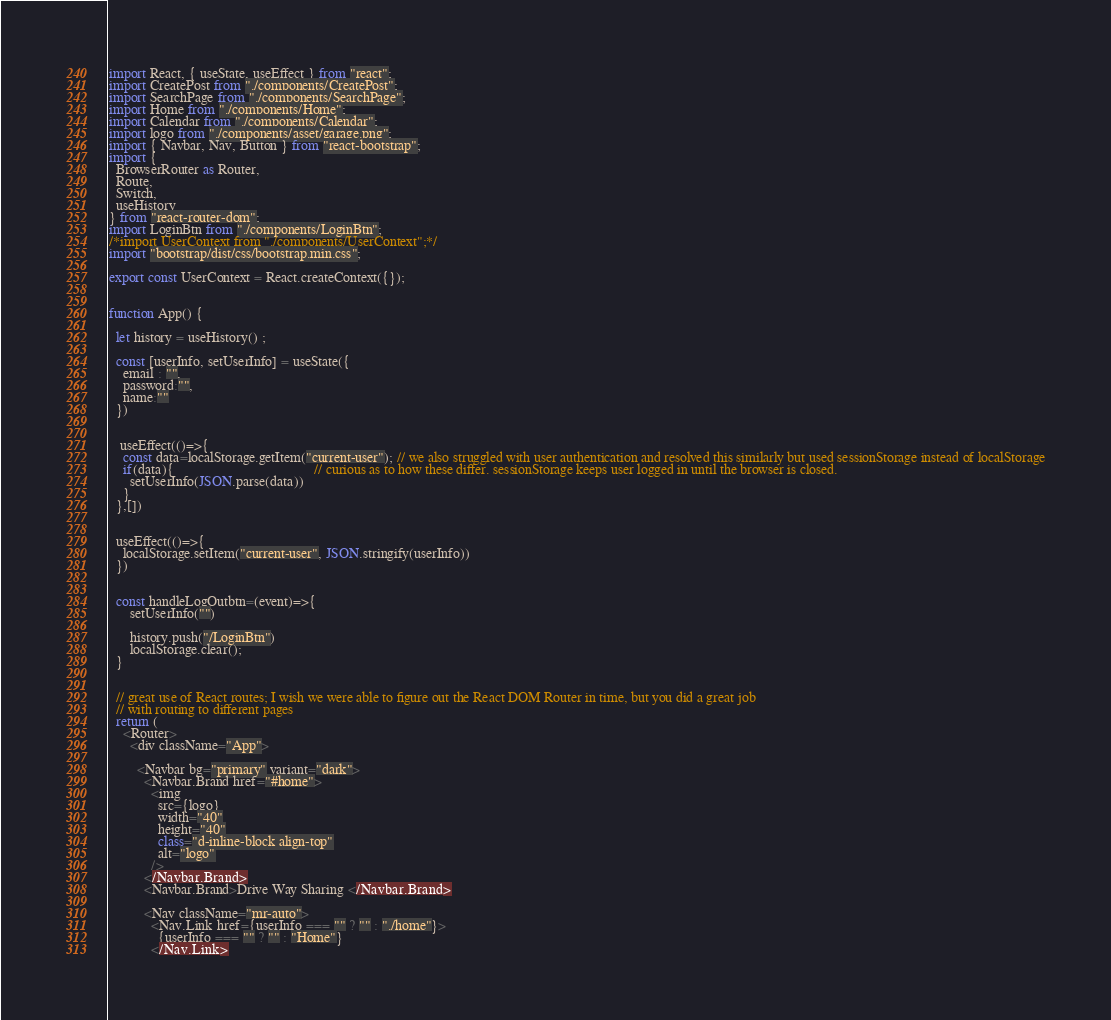<code> <loc_0><loc_0><loc_500><loc_500><_JavaScript_>import React, { useState, useEffect } from "react";
import CreatePost from "./components/CreatePost";
import SearchPage from "./components/SearchPage";
import Home from "./components/Home";
import Calendar from "./components/Calendar";
import logo from "./components/asset/garage.png";
import { Navbar, Nav, Button } from "react-bootstrap";
import {
  BrowserRouter as Router,
  Route,
  Switch,
  useHistory
} from "react-router-dom";
import LoginBtn from "./components/LoginBtn";
/*import UserContext from "./components/UserContext";*/
import "bootstrap/dist/css/bootstrap.min.css";

export const UserContext = React.createContext({});


function App() {

  let history = useHistory() ;

  const [userInfo, setUserInfo] = useState({
    email : "",
    password:"",
    name:""
  })


   useEffect(()=>{
    const data=localStorage.getItem("current-user"); // we also struggled with user authentication and resolved this similarly but used sessionStorage instead of localStorage
    if(data){                                        // curious as to how these differ. sessionStorage keeps user logged in until the browser is closed.
      setUserInfo(JSON.parse(data))
    }
  },[])


  useEffect(()=>{
    localStorage.setItem("current-user", JSON.stringify(userInfo))
  })


  const handleLogOutbtn=(event)=>{
      setUserInfo("")
      
      history.push("/LoginBtn")
      localStorage.clear();
  }


  // great use of React routes; I wish we were able to figure out the React DOM Router in time, but you did a great job
  // with routing to different pages
  return (
    <Router>
      <div className="App">
      
        <Navbar bg="primary" variant="dark">
          <Navbar.Brand href="#home">
            <img
              src={logo}
              width="40"
              height="40"
              class="d-inline-block align-top"
              alt="logo"
            />
          </Navbar.Brand>
          <Navbar.Brand>Drive Way Sharing </Navbar.Brand>

          <Nav className="mr-auto">
            <Nav.Link href={userInfo === "" ? "" : "./home"}>
              {userInfo === "" ? "" : "Home"}
            </Nav.Link></code> 